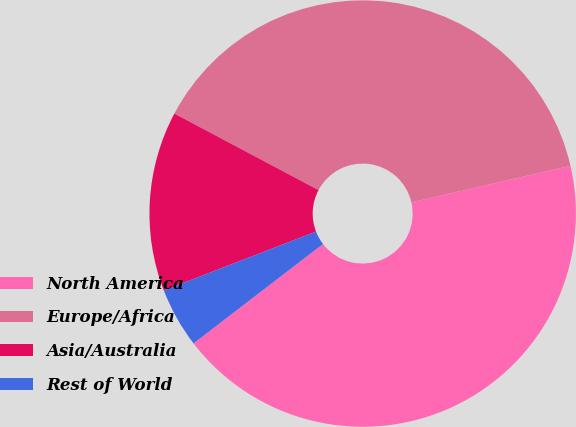<chart> <loc_0><loc_0><loc_500><loc_500><pie_chart><fcel>North America<fcel>Europe/Africa<fcel>Asia/Australia<fcel>Rest of World<nl><fcel>43.18%<fcel>38.64%<fcel>13.64%<fcel>4.55%<nl></chart> 